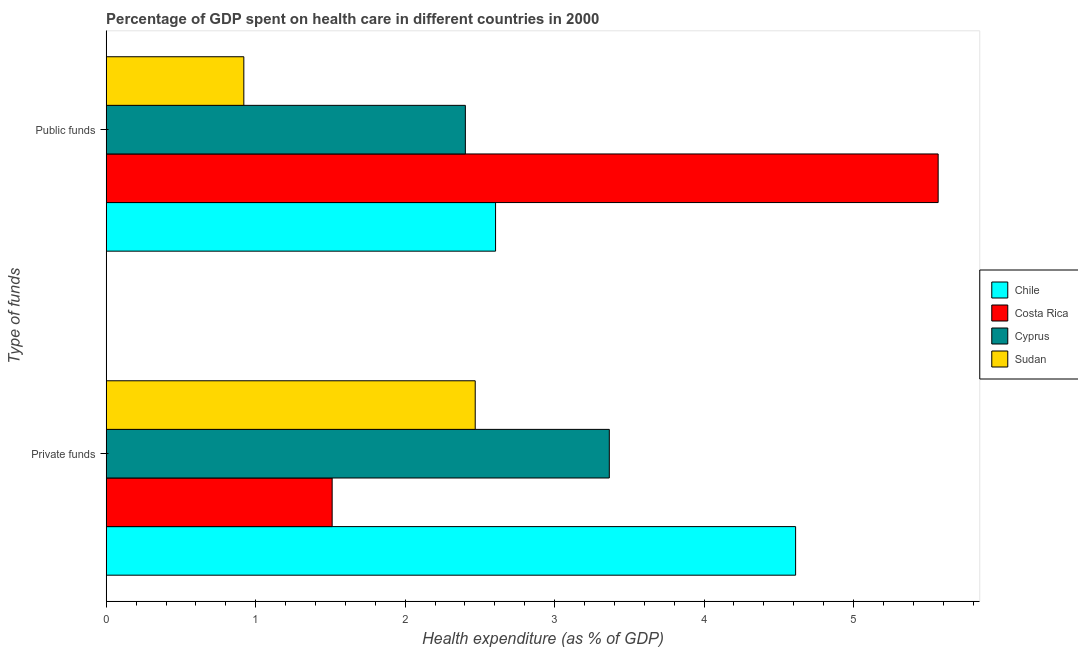How many groups of bars are there?
Make the answer very short. 2. Are the number of bars per tick equal to the number of legend labels?
Offer a terse response. Yes. How many bars are there on the 1st tick from the bottom?
Your answer should be very brief. 4. What is the label of the 1st group of bars from the top?
Give a very brief answer. Public funds. What is the amount of private funds spent in healthcare in Sudan?
Give a very brief answer. 2.47. Across all countries, what is the maximum amount of public funds spent in healthcare?
Give a very brief answer. 5.57. Across all countries, what is the minimum amount of public funds spent in healthcare?
Your answer should be compact. 0.92. In which country was the amount of public funds spent in healthcare maximum?
Provide a short and direct response. Costa Rica. In which country was the amount of public funds spent in healthcare minimum?
Your response must be concise. Sudan. What is the total amount of public funds spent in healthcare in the graph?
Offer a very short reply. 11.49. What is the difference between the amount of public funds spent in healthcare in Sudan and that in Chile?
Your response must be concise. -1.68. What is the difference between the amount of private funds spent in healthcare in Sudan and the amount of public funds spent in healthcare in Costa Rica?
Offer a very short reply. -3.1. What is the average amount of public funds spent in healthcare per country?
Your answer should be very brief. 2.87. What is the difference between the amount of private funds spent in healthcare and amount of public funds spent in healthcare in Cyprus?
Offer a very short reply. 0.96. In how many countries, is the amount of private funds spent in healthcare greater than 2 %?
Keep it short and to the point. 3. What is the ratio of the amount of private funds spent in healthcare in Cyprus to that in Costa Rica?
Make the answer very short. 2.23. In how many countries, is the amount of private funds spent in healthcare greater than the average amount of private funds spent in healthcare taken over all countries?
Provide a short and direct response. 2. What does the 3rd bar from the top in Private funds represents?
Your response must be concise. Costa Rica. What does the 4th bar from the bottom in Private funds represents?
Offer a terse response. Sudan. Are all the bars in the graph horizontal?
Offer a terse response. Yes. Are the values on the major ticks of X-axis written in scientific E-notation?
Your response must be concise. No. Does the graph contain any zero values?
Provide a succinct answer. No. Where does the legend appear in the graph?
Provide a succinct answer. Center right. How many legend labels are there?
Keep it short and to the point. 4. What is the title of the graph?
Offer a terse response. Percentage of GDP spent on health care in different countries in 2000. Does "El Salvador" appear as one of the legend labels in the graph?
Your response must be concise. No. What is the label or title of the X-axis?
Your answer should be very brief. Health expenditure (as % of GDP). What is the label or title of the Y-axis?
Your response must be concise. Type of funds. What is the Health expenditure (as % of GDP) in Chile in Private funds?
Provide a short and direct response. 4.61. What is the Health expenditure (as % of GDP) in Costa Rica in Private funds?
Give a very brief answer. 1.51. What is the Health expenditure (as % of GDP) in Cyprus in Private funds?
Ensure brevity in your answer.  3.37. What is the Health expenditure (as % of GDP) in Sudan in Private funds?
Offer a terse response. 2.47. What is the Health expenditure (as % of GDP) in Chile in Public funds?
Give a very brief answer. 2.6. What is the Health expenditure (as % of GDP) in Costa Rica in Public funds?
Your answer should be compact. 5.57. What is the Health expenditure (as % of GDP) in Cyprus in Public funds?
Make the answer very short. 2.4. What is the Health expenditure (as % of GDP) in Sudan in Public funds?
Provide a succinct answer. 0.92. Across all Type of funds, what is the maximum Health expenditure (as % of GDP) of Chile?
Make the answer very short. 4.61. Across all Type of funds, what is the maximum Health expenditure (as % of GDP) in Costa Rica?
Your response must be concise. 5.57. Across all Type of funds, what is the maximum Health expenditure (as % of GDP) in Cyprus?
Keep it short and to the point. 3.37. Across all Type of funds, what is the maximum Health expenditure (as % of GDP) of Sudan?
Keep it short and to the point. 2.47. Across all Type of funds, what is the minimum Health expenditure (as % of GDP) of Chile?
Provide a succinct answer. 2.6. Across all Type of funds, what is the minimum Health expenditure (as % of GDP) of Costa Rica?
Your answer should be compact. 1.51. Across all Type of funds, what is the minimum Health expenditure (as % of GDP) in Cyprus?
Make the answer very short. 2.4. Across all Type of funds, what is the minimum Health expenditure (as % of GDP) in Sudan?
Offer a terse response. 0.92. What is the total Health expenditure (as % of GDP) in Chile in the graph?
Give a very brief answer. 7.22. What is the total Health expenditure (as % of GDP) in Costa Rica in the graph?
Keep it short and to the point. 7.08. What is the total Health expenditure (as % of GDP) of Cyprus in the graph?
Your answer should be very brief. 5.77. What is the total Health expenditure (as % of GDP) of Sudan in the graph?
Your response must be concise. 3.39. What is the difference between the Health expenditure (as % of GDP) in Chile in Private funds and that in Public funds?
Make the answer very short. 2.01. What is the difference between the Health expenditure (as % of GDP) in Costa Rica in Private funds and that in Public funds?
Ensure brevity in your answer.  -4.05. What is the difference between the Health expenditure (as % of GDP) of Cyprus in Private funds and that in Public funds?
Offer a terse response. 0.96. What is the difference between the Health expenditure (as % of GDP) of Sudan in Private funds and that in Public funds?
Your answer should be compact. 1.55. What is the difference between the Health expenditure (as % of GDP) of Chile in Private funds and the Health expenditure (as % of GDP) of Costa Rica in Public funds?
Your response must be concise. -0.95. What is the difference between the Health expenditure (as % of GDP) of Chile in Private funds and the Health expenditure (as % of GDP) of Cyprus in Public funds?
Your answer should be very brief. 2.21. What is the difference between the Health expenditure (as % of GDP) of Chile in Private funds and the Health expenditure (as % of GDP) of Sudan in Public funds?
Give a very brief answer. 3.69. What is the difference between the Health expenditure (as % of GDP) of Costa Rica in Private funds and the Health expenditure (as % of GDP) of Cyprus in Public funds?
Your response must be concise. -0.89. What is the difference between the Health expenditure (as % of GDP) in Costa Rica in Private funds and the Health expenditure (as % of GDP) in Sudan in Public funds?
Provide a short and direct response. 0.59. What is the difference between the Health expenditure (as % of GDP) of Cyprus in Private funds and the Health expenditure (as % of GDP) of Sudan in Public funds?
Your response must be concise. 2.45. What is the average Health expenditure (as % of GDP) of Chile per Type of funds?
Make the answer very short. 3.61. What is the average Health expenditure (as % of GDP) in Costa Rica per Type of funds?
Your answer should be very brief. 3.54. What is the average Health expenditure (as % of GDP) in Cyprus per Type of funds?
Offer a very short reply. 2.88. What is the average Health expenditure (as % of GDP) of Sudan per Type of funds?
Your answer should be very brief. 1.69. What is the difference between the Health expenditure (as % of GDP) in Chile and Health expenditure (as % of GDP) in Costa Rica in Private funds?
Your answer should be very brief. 3.1. What is the difference between the Health expenditure (as % of GDP) in Chile and Health expenditure (as % of GDP) in Cyprus in Private funds?
Make the answer very short. 1.25. What is the difference between the Health expenditure (as % of GDP) in Chile and Health expenditure (as % of GDP) in Sudan in Private funds?
Your answer should be compact. 2.14. What is the difference between the Health expenditure (as % of GDP) of Costa Rica and Health expenditure (as % of GDP) of Cyprus in Private funds?
Offer a very short reply. -1.85. What is the difference between the Health expenditure (as % of GDP) in Costa Rica and Health expenditure (as % of GDP) in Sudan in Private funds?
Keep it short and to the point. -0.96. What is the difference between the Health expenditure (as % of GDP) in Cyprus and Health expenditure (as % of GDP) in Sudan in Private funds?
Keep it short and to the point. 0.9. What is the difference between the Health expenditure (as % of GDP) of Chile and Health expenditure (as % of GDP) of Costa Rica in Public funds?
Your answer should be very brief. -2.96. What is the difference between the Health expenditure (as % of GDP) of Chile and Health expenditure (as % of GDP) of Cyprus in Public funds?
Your response must be concise. 0.2. What is the difference between the Health expenditure (as % of GDP) of Chile and Health expenditure (as % of GDP) of Sudan in Public funds?
Provide a succinct answer. 1.68. What is the difference between the Health expenditure (as % of GDP) of Costa Rica and Health expenditure (as % of GDP) of Cyprus in Public funds?
Give a very brief answer. 3.16. What is the difference between the Health expenditure (as % of GDP) of Costa Rica and Health expenditure (as % of GDP) of Sudan in Public funds?
Keep it short and to the point. 4.65. What is the difference between the Health expenditure (as % of GDP) in Cyprus and Health expenditure (as % of GDP) in Sudan in Public funds?
Give a very brief answer. 1.48. What is the ratio of the Health expenditure (as % of GDP) of Chile in Private funds to that in Public funds?
Your answer should be very brief. 1.77. What is the ratio of the Health expenditure (as % of GDP) in Costa Rica in Private funds to that in Public funds?
Your response must be concise. 0.27. What is the ratio of the Health expenditure (as % of GDP) of Cyprus in Private funds to that in Public funds?
Ensure brevity in your answer.  1.4. What is the ratio of the Health expenditure (as % of GDP) in Sudan in Private funds to that in Public funds?
Offer a very short reply. 2.68. What is the difference between the highest and the second highest Health expenditure (as % of GDP) of Chile?
Keep it short and to the point. 2.01. What is the difference between the highest and the second highest Health expenditure (as % of GDP) of Costa Rica?
Ensure brevity in your answer.  4.05. What is the difference between the highest and the second highest Health expenditure (as % of GDP) in Cyprus?
Your answer should be very brief. 0.96. What is the difference between the highest and the second highest Health expenditure (as % of GDP) in Sudan?
Your answer should be compact. 1.55. What is the difference between the highest and the lowest Health expenditure (as % of GDP) of Chile?
Your answer should be very brief. 2.01. What is the difference between the highest and the lowest Health expenditure (as % of GDP) of Costa Rica?
Give a very brief answer. 4.05. What is the difference between the highest and the lowest Health expenditure (as % of GDP) in Cyprus?
Provide a short and direct response. 0.96. What is the difference between the highest and the lowest Health expenditure (as % of GDP) of Sudan?
Make the answer very short. 1.55. 